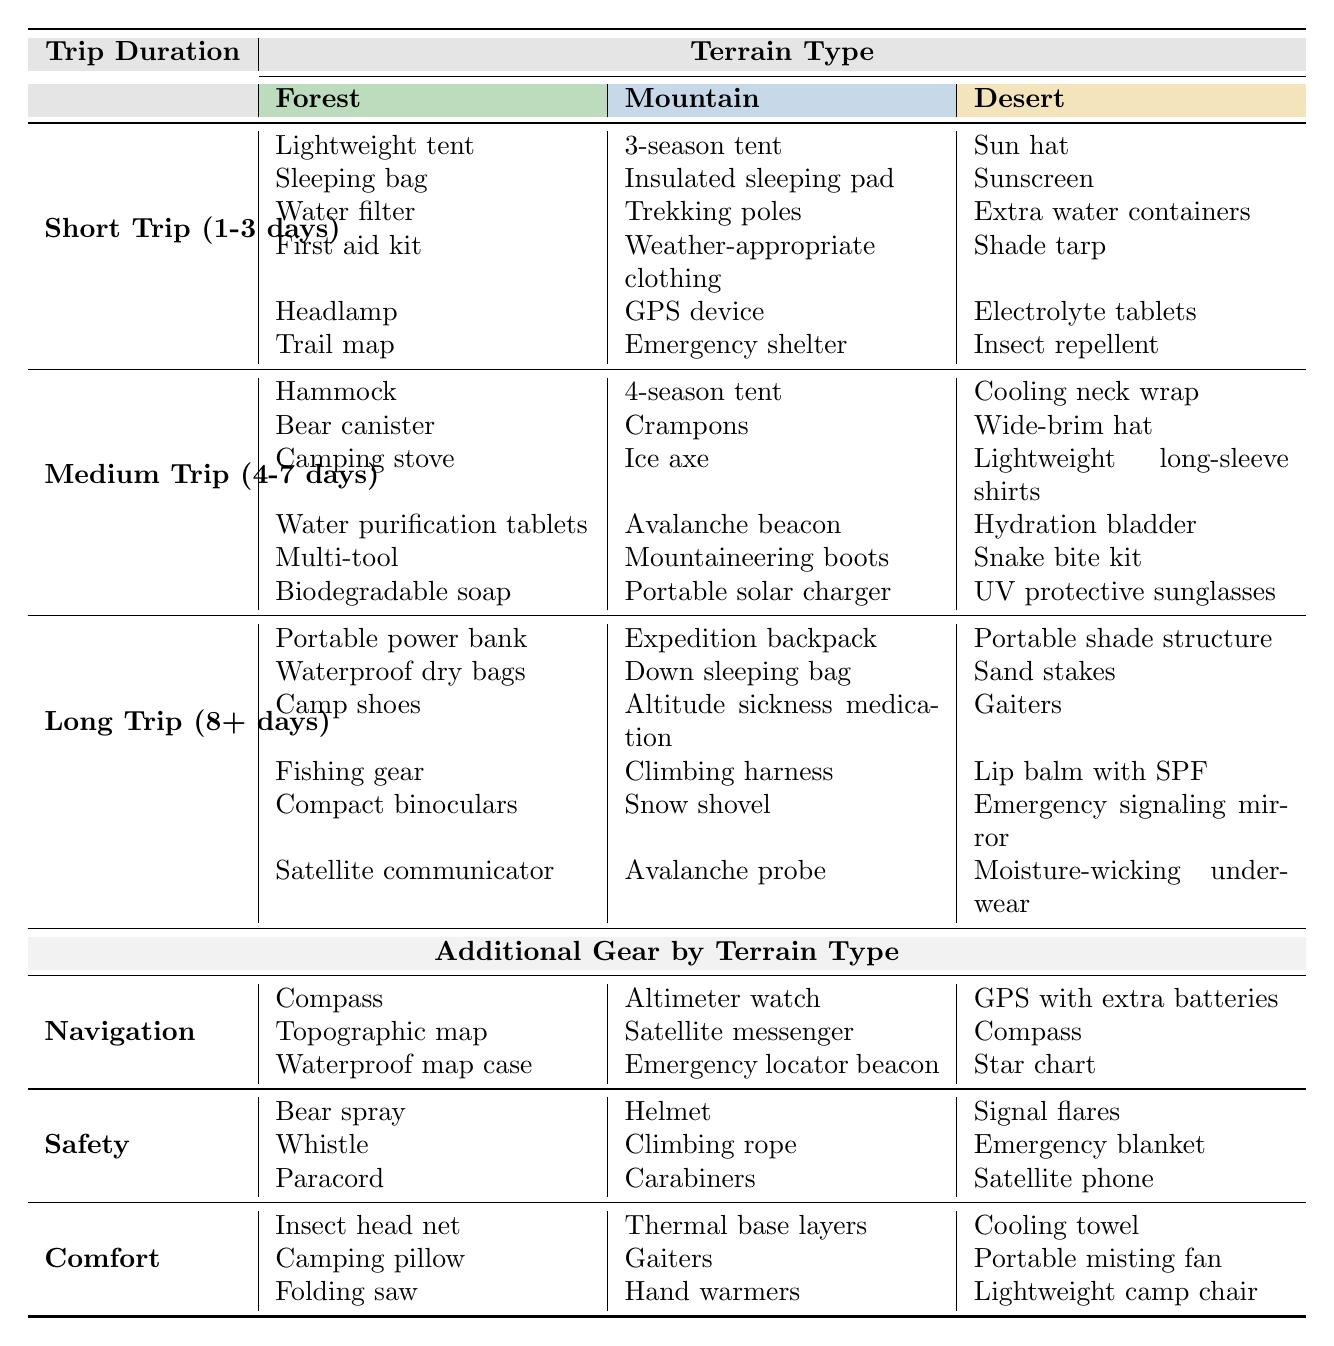What gear is recommended for a short trip to the desert? In the "Short Trip (1-3 days)" section under "Desert," the recommended gear includes: Sun hat, Sunscreen, Extra water containers, Shade tarp, Electrolyte tablets, Insect repellent.
Answer: Sun hat, Sunscreen, Extra water containers, Shade tarp, Electrolyte tablets, Insect repellent How many items are listed for medium trips in the forest? In the "Medium Trip (4-7 days)" section under "Forest," there are 6 items listed: Hammock, Bear canister, Camping stove, Water purification tablets, Multi-tool, Biodegradable soap. Therefore, the total count is 6.
Answer: 6 Is a portable solar charger necessary for a long trip in the mountains? Yes, a portable solar charger is listed as necessary gear for long trips in the "Mountain" section.
Answer: Yes What is the difference in the number of gear items between short and medium trips in the forest? For "Short Trip (1-3 days)" in the Forest, there are 6 items; for "Medium Trip (4-7 days)" in the Forest, there are also 6 items. The difference is 6 - 6 = 0.
Answer: 0 Is a lightweight long-sleeve shirt included in the gear for medium desert trips? Yes, a lightweight long-sleeve shirt is listed in the "Medium Trip (4-7 days)" section under "Desert."
Answer: Yes What additional gear items are listed for navigation across all terrain types? For Navigation, the gear items are: Compass, Topographic map, Waterproof map case for Forest; Altimeter watch, Satellite messenger, Emergency locator beacon for Mountain; GPS with extra batteries, Compass, Star chart for Desert. Total, there are 3 items listed per terrain type.
Answer: 9 How many safety items are recommended for mountain terrain during medium trips? In the "Medium Trip (4-7 days)" under "Mountain," the safety items listed are: Helmet, Climbing rope, Carabiners, which totals to 3 items.
Answer: 3 List all the comfort items available for desert terrain. For the "Desert," the comfort items listed are: Cooling towel, Portable misting fan, Lightweight camp chair, totaling to 3 comfort items.
Answer: 3 items: Cooling towel, Portable misting fan, Lightweight camp chair What is the total number of items listed for all categories within the short trip section? For the short trip section: Forest has 6 items, Mountain has 6 items, Desert has 6 items. Therefore, the total is 6 + 6 + 6 = 18.
Answer: 18 Which specific gear item is unique to long trips in the forest compared to other terrains? The unique item listed for long trips in the forest that is not found in other terrains is the "Satellite communicator."
Answer: Satellite communicator 